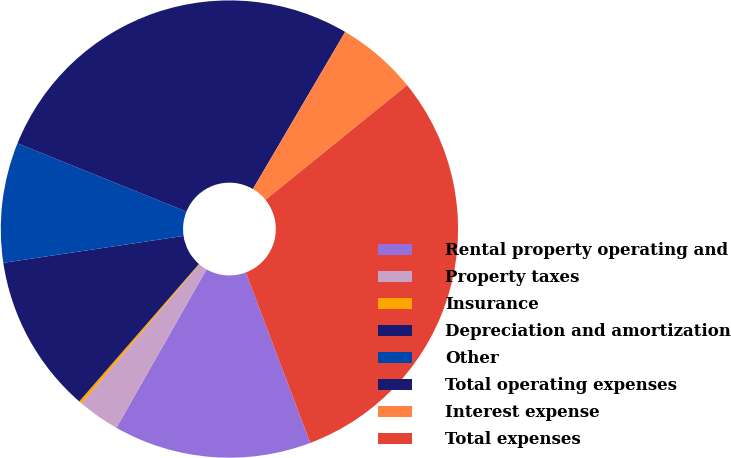Convert chart to OTSL. <chart><loc_0><loc_0><loc_500><loc_500><pie_chart><fcel>Rental property operating and<fcel>Property taxes<fcel>Insurance<fcel>Depreciation and amortization<fcel>Other<fcel>Total operating expenses<fcel>Interest expense<fcel>Total expenses<nl><fcel>13.98%<fcel>2.97%<fcel>0.21%<fcel>11.23%<fcel>8.48%<fcel>27.33%<fcel>5.72%<fcel>30.08%<nl></chart> 